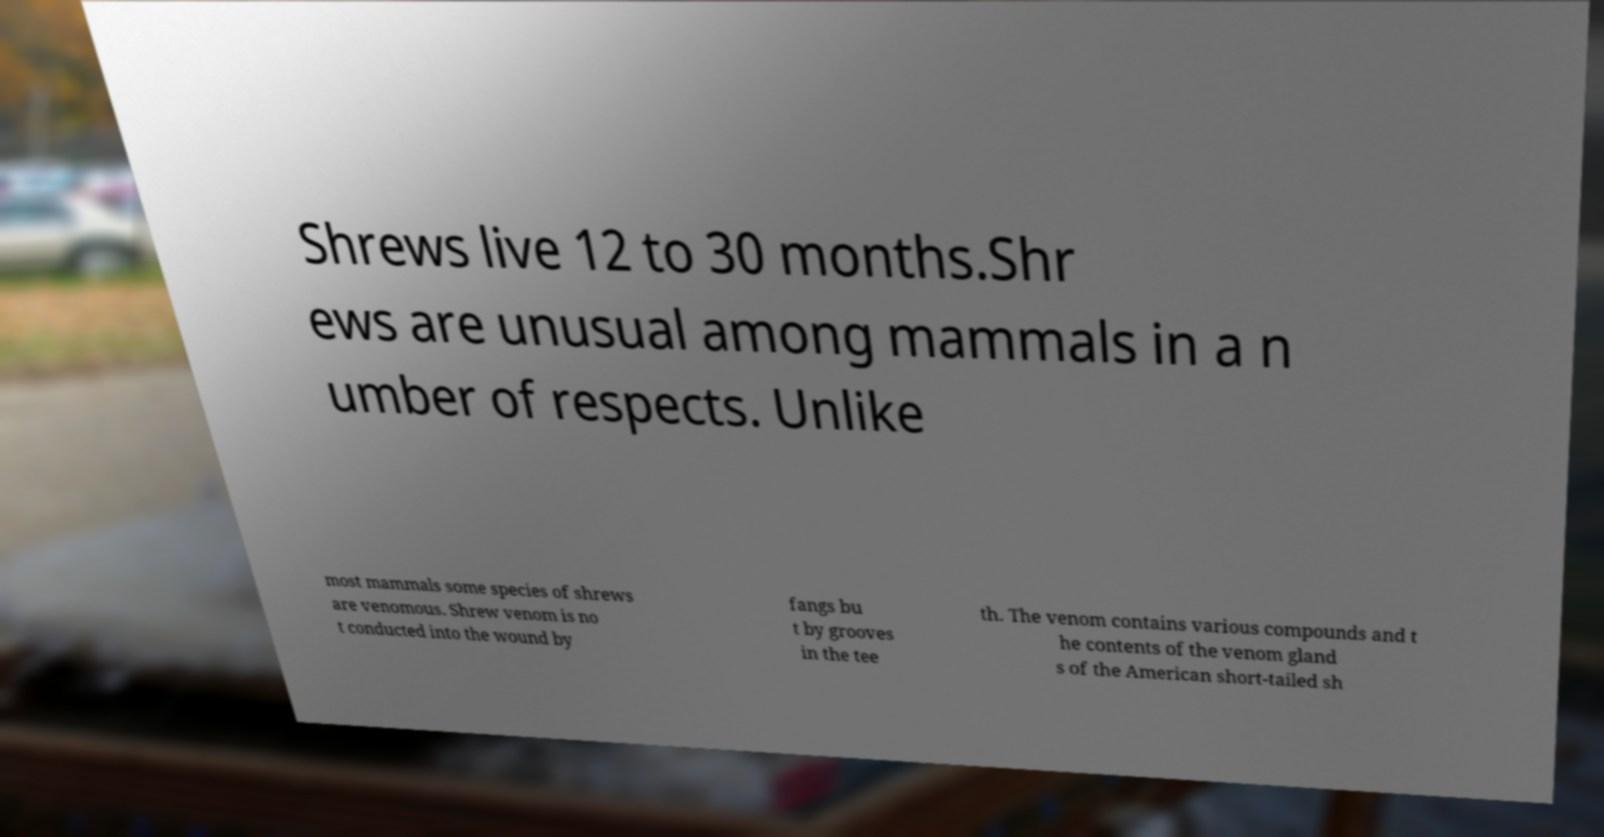Can you accurately transcribe the text from the provided image for me? Shrews live 12 to 30 months.Shr ews are unusual among mammals in a n umber of respects. Unlike most mammals some species of shrews are venomous. Shrew venom is no t conducted into the wound by fangs bu t by grooves in the tee th. The venom contains various compounds and t he contents of the venom gland s of the American short-tailed sh 